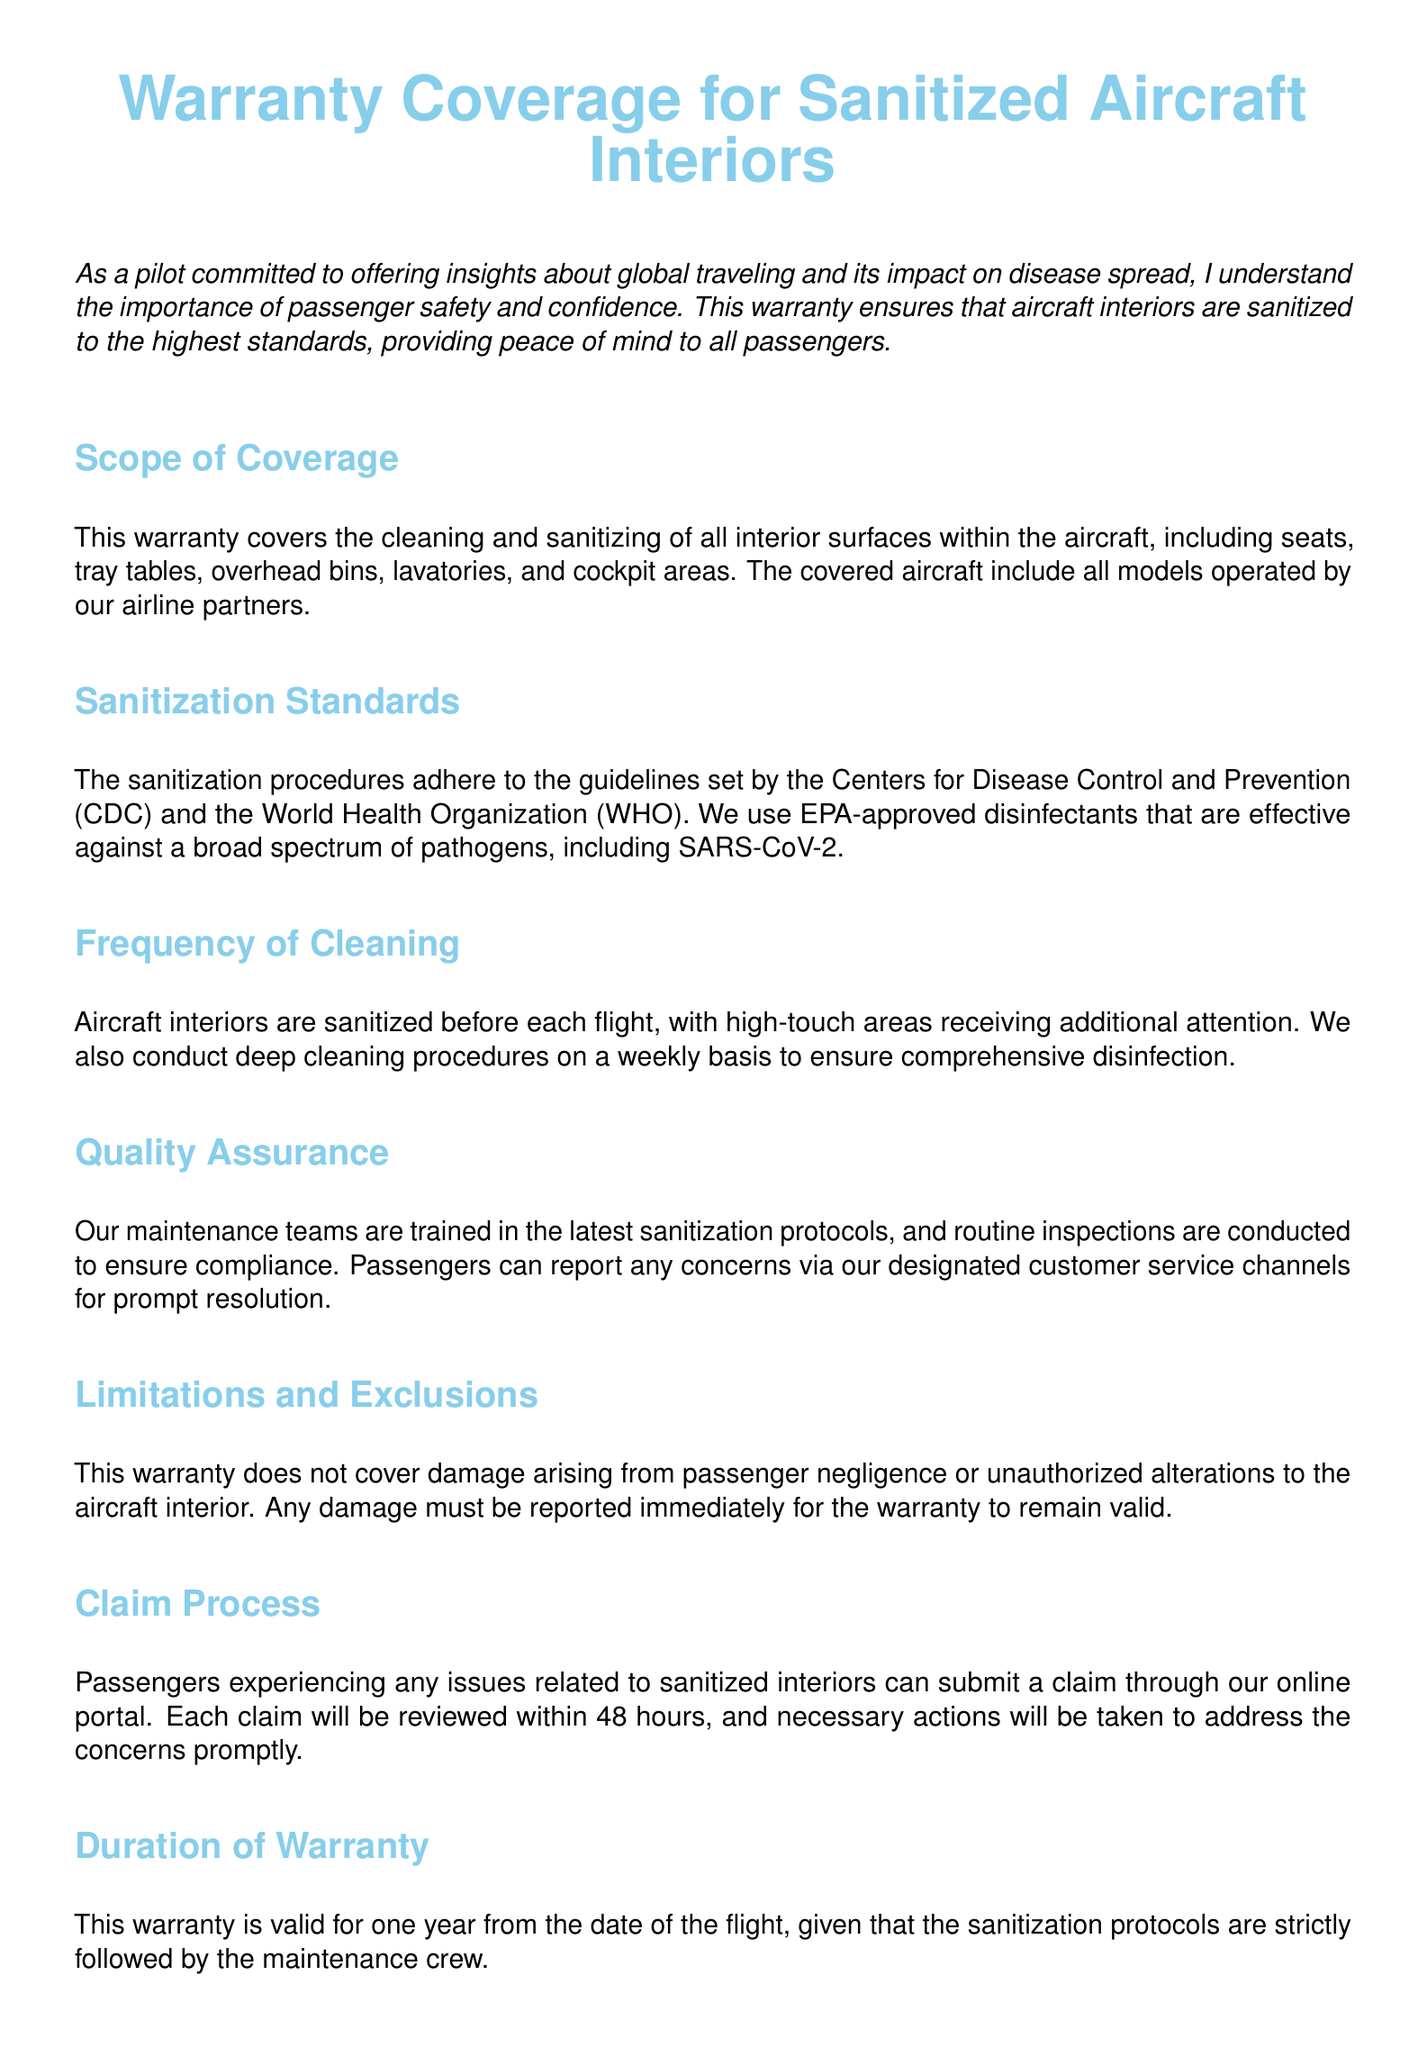What is covered under the warranty? The warranty covers the cleaning and sanitizing of all interior surfaces within the aircraft, including seats, tray tables, overhead bins, lavatories, and cockpit areas.
Answer: Cleaning and sanitizing of all interior surfaces Which organizations' guidelines does the sanitization procedures adhere to? The sanitization procedures adhere to the guidelines set by the Centers for Disease Control and Prevention and the World Health Organization.
Answer: CDC and WHO How often are aircraft interiors sanitized? Aircraft interiors are sanitized before each flight, with high-touch areas receiving additional attention.
Answer: Before each flight What is the duration of the warranty? The warranty is valid for one year from the date of the flight, provided the sanitization protocols are strictly followed.
Answer: One year What must be reported immediately to maintain warranty validity? Any damage must be reported immediately for the warranty to remain valid.
Answer: Damage Where can passengers submit a claim related to sanitized interiors? Passengers can submit a claim through the online portal.
Answer: Online portal What type of training do maintenance teams receive? Maintenance teams are trained in the latest sanitization protocols.
Answer: Latest sanitization protocols What is the contact email for customer service? For more information or to make a claim, the contact email is provided in the document.
Answer: support@airlinesafety.com 